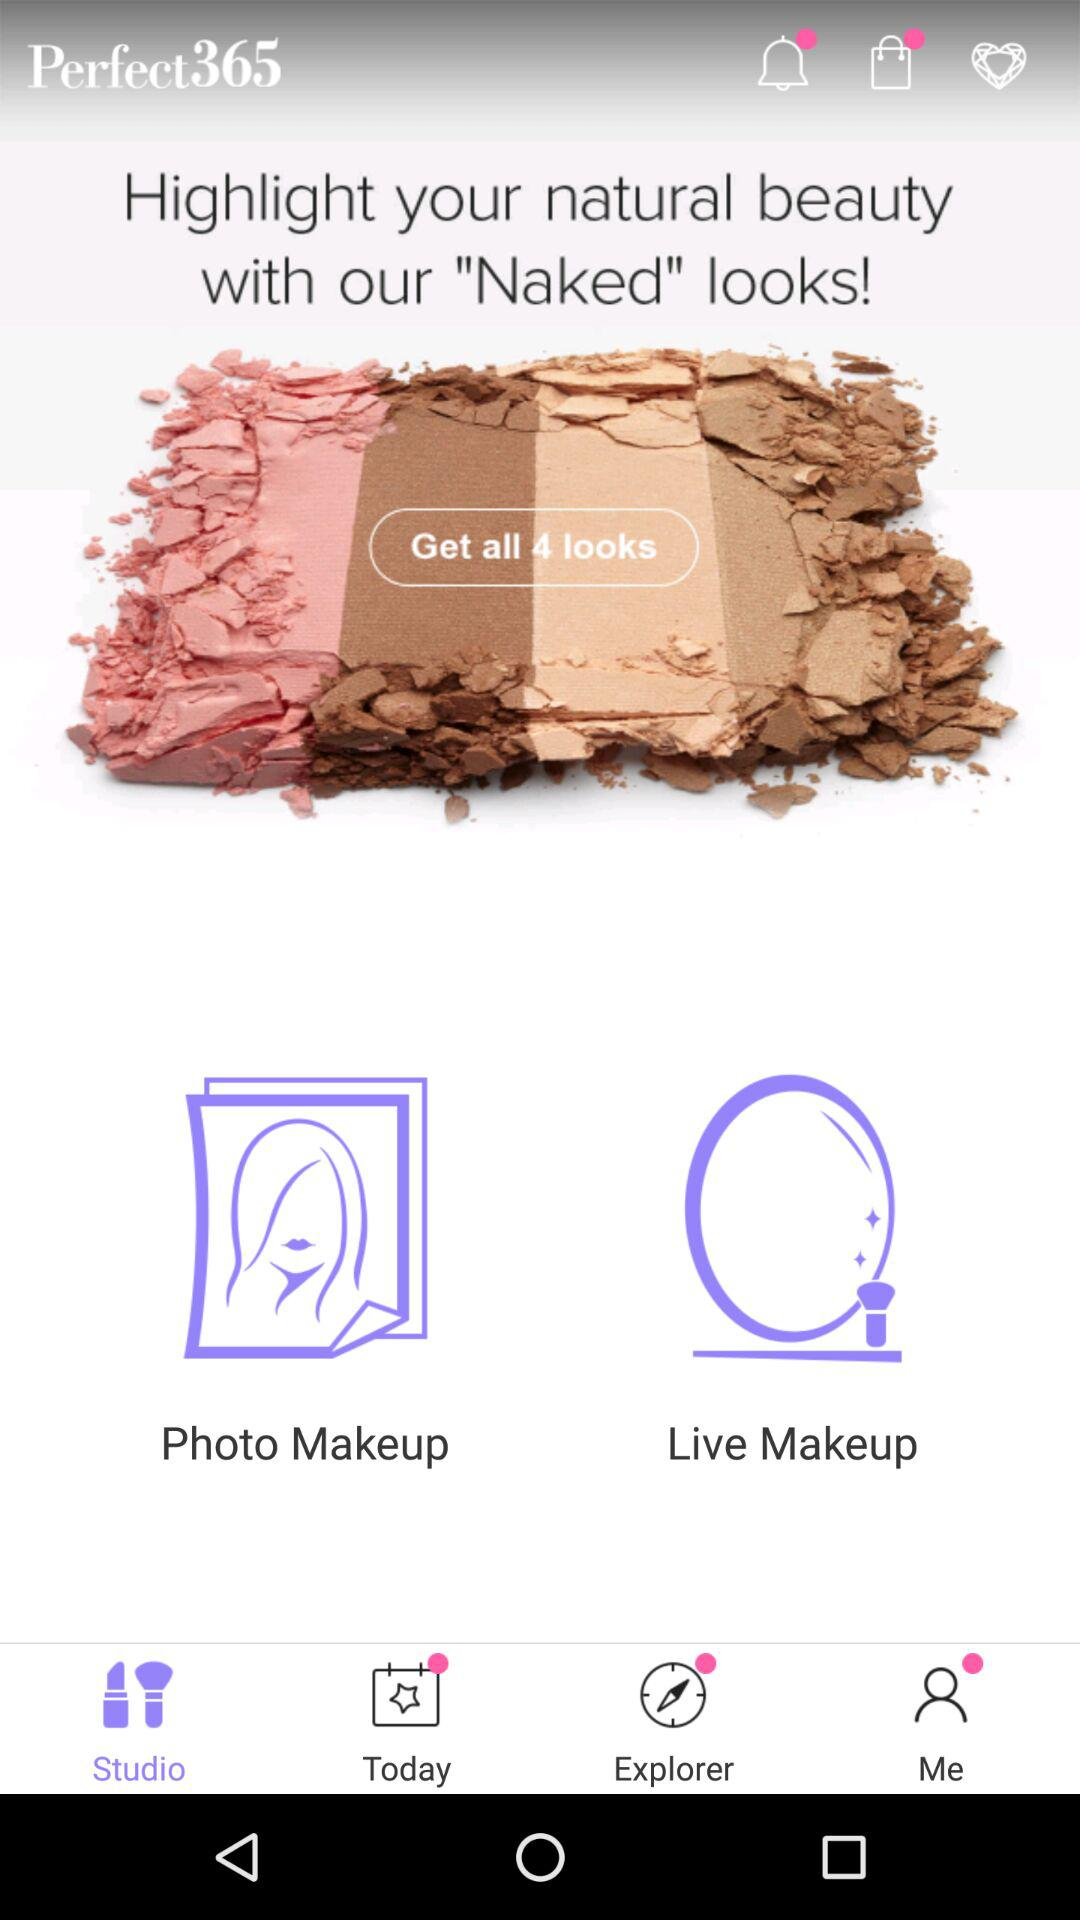What is the application name? The application name is "Perfect365". 